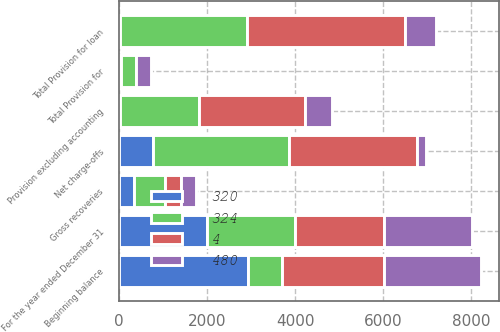Convert chart to OTSL. <chart><loc_0><loc_0><loc_500><loc_500><stacked_bar_chart><ecel><fcel>For the year ended December 31<fcel>Beginning balance<fcel>Gross recoveries<fcel>Net charge-offs<fcel>Provision excluding accounting<fcel>Total Provision for loan<fcel>Total Provision for<nl><fcel>480<fcel>2004<fcel>2204<fcel>357<fcel>186<fcel>605<fcel>708<fcel>338<nl><fcel>4<fcel>2004<fcel>2319<fcel>349<fcel>2913<fcel>2403<fcel>3591<fcel>1<nl><fcel>324<fcel>2004<fcel>765<fcel>706<fcel>3099<fcel>1798<fcel>2883<fcel>339<nl><fcel>320<fcel>2003<fcel>2936<fcel>348<fcel>765<fcel>25<fcel>25<fcel>40<nl></chart> 